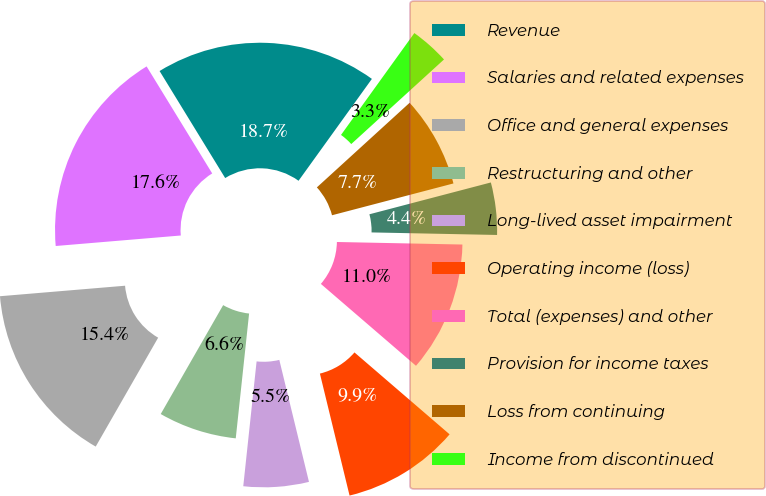<chart> <loc_0><loc_0><loc_500><loc_500><pie_chart><fcel>Revenue<fcel>Salaries and related expenses<fcel>Office and general expenses<fcel>Restructuring and other<fcel>Long-lived asset impairment<fcel>Operating income (loss)<fcel>Total (expenses) and other<fcel>Provision for income taxes<fcel>Loss from continuing<fcel>Income from discontinued<nl><fcel>18.68%<fcel>17.58%<fcel>15.38%<fcel>6.59%<fcel>5.49%<fcel>9.89%<fcel>10.99%<fcel>4.4%<fcel>7.69%<fcel>3.3%<nl></chart> 